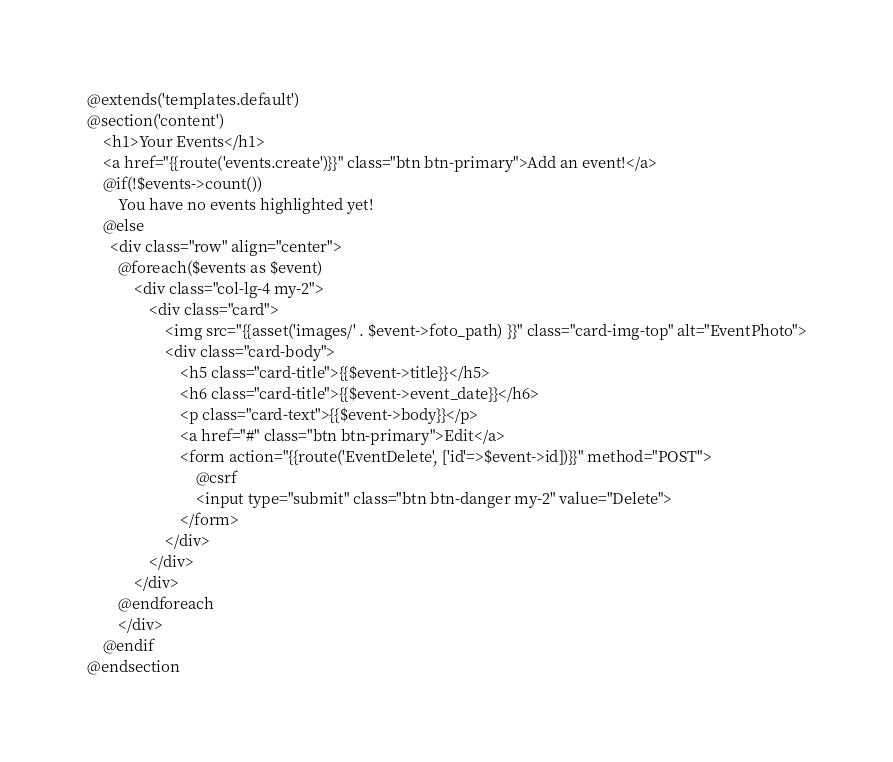<code> <loc_0><loc_0><loc_500><loc_500><_PHP_>@extends('templates.default')
@section('content')
    <h1>Your Events</h1>
    <a href="{{route('events.create')}}" class="btn btn-primary">Add an event!</a>
    @if(!$events->count())
        You have no events highlighted yet!
    @else
      <div class="row" align="center">
        @foreach($events as $event)
            <div class="col-lg-4 my-2">
                <div class="card">
                    <img src="{{asset('images/' . $event->foto_path) }}" class="card-img-top" alt="EventPhoto">
                    <div class="card-body">
                        <h5 class="card-title">{{$event->title}}</h5>
                        <h6 class="card-title">{{$event->event_date}}</h6>
                        <p class="card-text">{{$event->body}}</p>
                        <a href="#" class="btn btn-primary">Edit</a>
                        <form action="{{route('EventDelete', ['id'=>$event->id])}}" method="POST">
                            @csrf
                            <input type="submit" class="btn btn-danger my-2" value="Delete">
                        </form>
                    </div>
                </div>
            </div>
        @endforeach
        </div>
    @endif
@endsection
</code> 